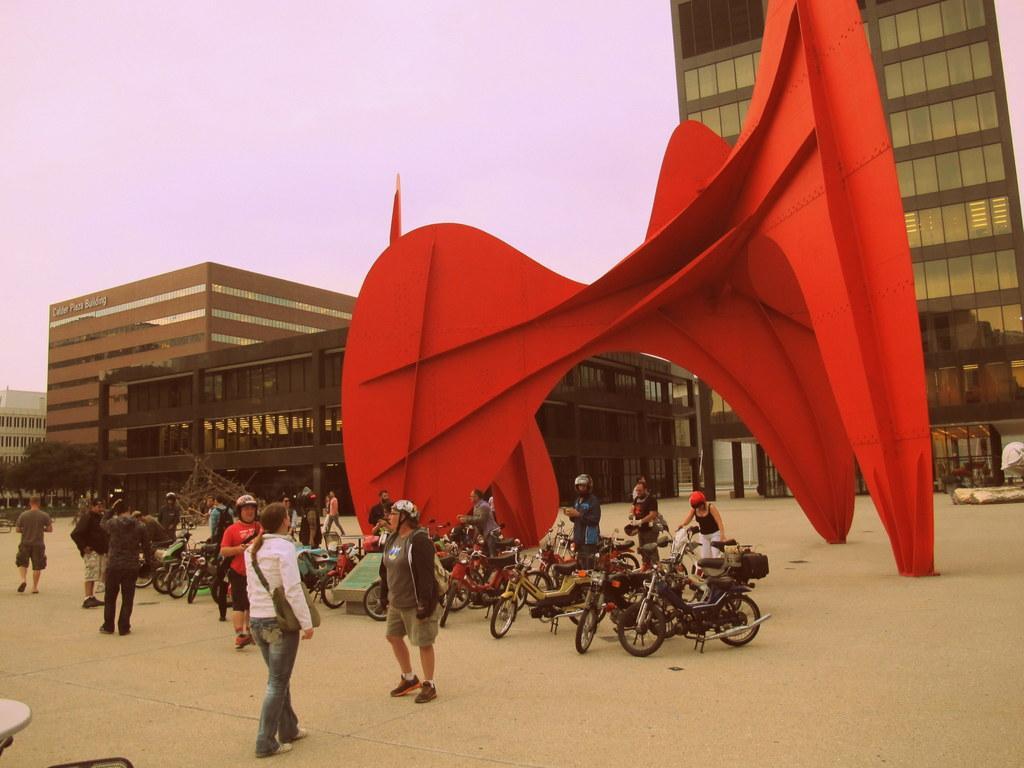Describe this image in one or two sentences. In this image, there are groups of people standing. These are the motorbikes, which are parked. I can see the buildings with glass doors. This looks like a modern sculpture, which is red in color. These are the trees. 